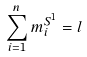<formula> <loc_0><loc_0><loc_500><loc_500>\sum _ { i = 1 } ^ { n } m _ { i } ^ { S ^ { 1 } } = l</formula> 